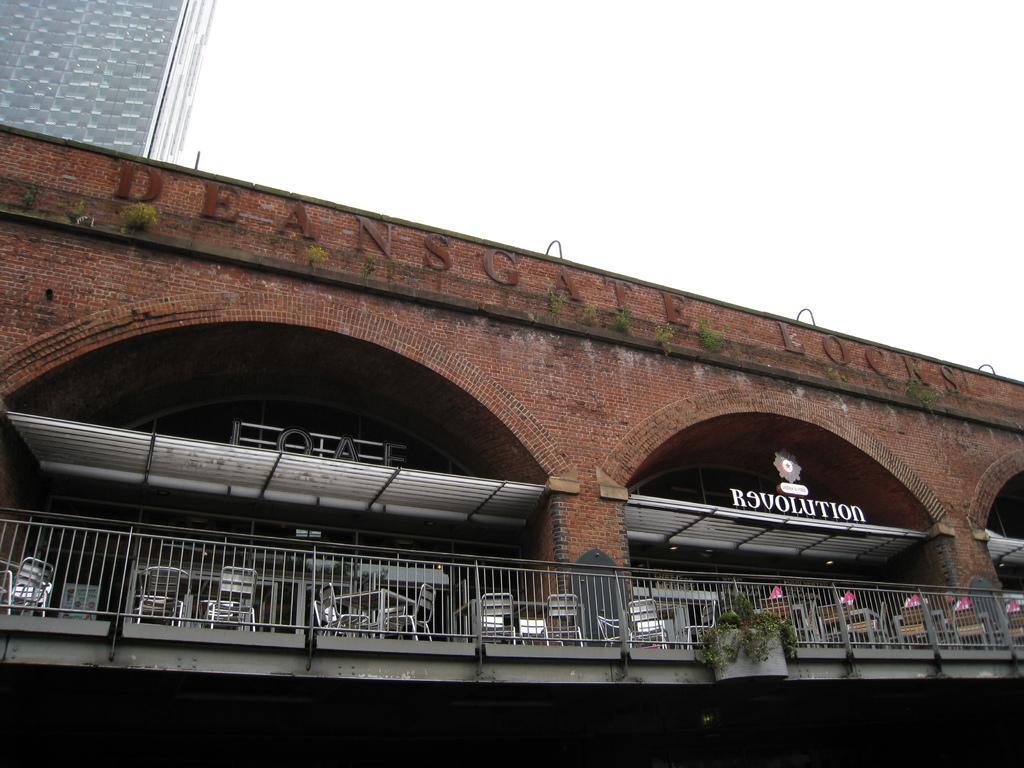Could you give a brief overview of what you see in this image? In this image we can see one big white glass building and one red building with some text on it. Some plants, some chairs with tables, two name board with logo board, some objects are on the surface, one iron fence near and at the top there is the sky. 